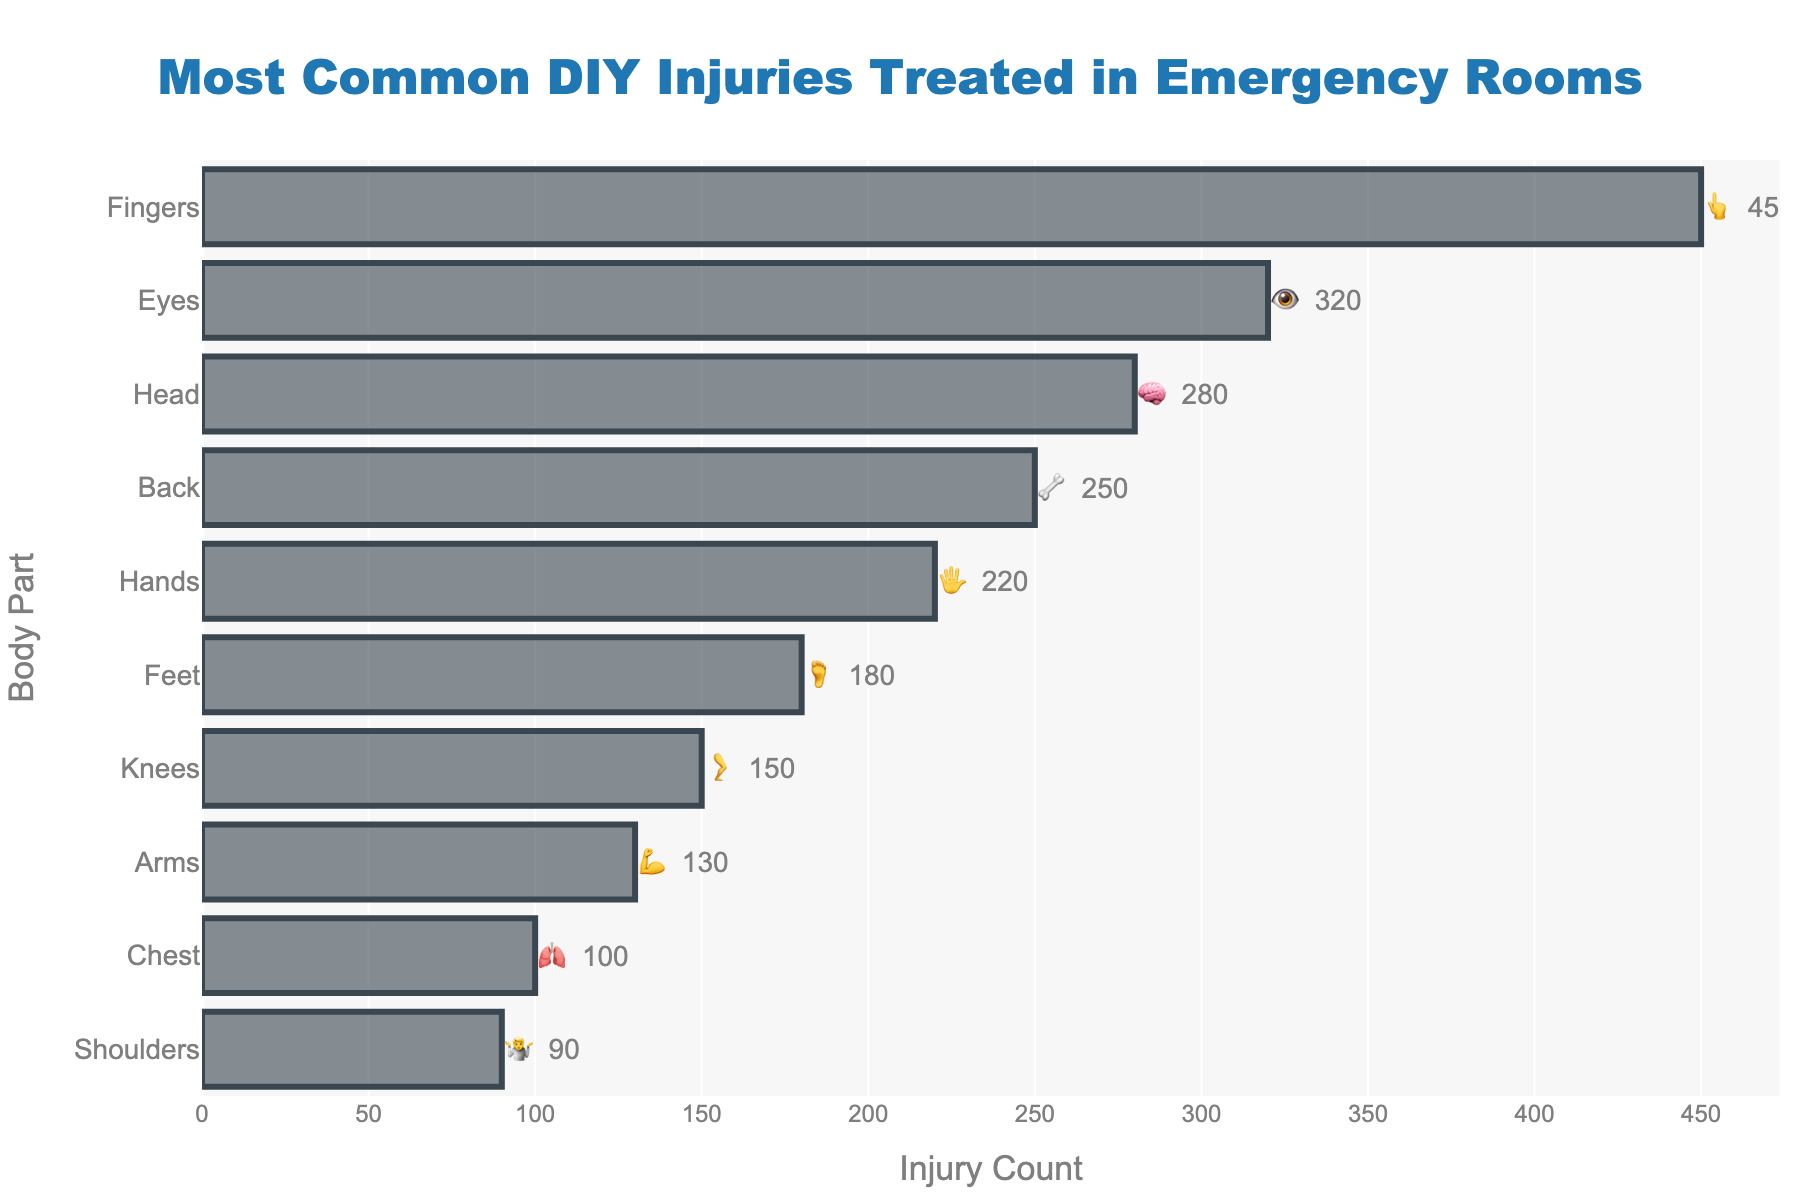What's the title of the chart? The title is usually displayed at the top of the chart, clearly indicating what the chart is about. In this case, it's located at the top of the chart as "Most Common DIY Injuries Treated in Emergency Rooms".
Answer: Most Common DIY Injuries Treated in Emergency Rooms Which body part has the highest injury count? By looking at the horizontal bars, the body part with the longest bar corresponds to the highest injury count. In this chart, it's the bar for "Fingers" with 450 injuries.
Answer: Fingers How many injuries were reported for knees? Locate the bar corresponding to "Knees" on the y-axis, then check the length of the bar along the x-axis. The injury count displayed beside the bar is 150.
Answer: 150 What is the total number of injuries for all body parts combined? Sum the injury counts for each body part: 450 (Fingers) + 320 (Eyes) + 280 (Head) + 250 (Back) + 220 (Hands) + 180 (Feet) + 150 (Knees) + 130 (Arms) + 100 (Chest) + 90 (Shoulders). Adding these amounts gives a total of 2170 injuries.
Answer: 2170 Which body part has fewer injuries, Back or Feet, and by how much? Compare the injury counts for Back (250) and Feet (180). Subtract the smaller count from the larger one: 250 - 180 = 70. Therefore, Feet have fewer injuries by 70.
Answer: Feet, by 70 Which body parts have more than 200 injuries? Examine the injury counts and identify those greater than 200. Fingers (450), Eyes (320), Head (280), Back (250), and Hands (220) meet this criterion.
Answer: Fingers, Eyes, Head, Back, Hands What's the difference in injury count between the Head and the Chest? Compare the injury counts of Head (280) and Chest (100). Subtract the smaller count from the larger one: 280 - 100 = 180.
Answer: 180 Which body part has the lowest number of injuries? Identify the shortest bar on the chart and note the corresponding body part and injury count. Shoulders have the lowest count with 90 injuries.
Answer: Shoulders What is the average number of injuries for the given body parts? Calculate the sum of injury counts (2170) and divide by the number of body parts (10). The average is 2170 / 10 = 217.
Answer: 217 